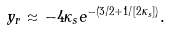Convert formula to latex. <formula><loc_0><loc_0><loc_500><loc_500>y _ { r } \approx - 4 \kappa _ { s } e ^ { - ( 3 / 2 + 1 / [ 2 \kappa _ { s } ] ) } .</formula> 